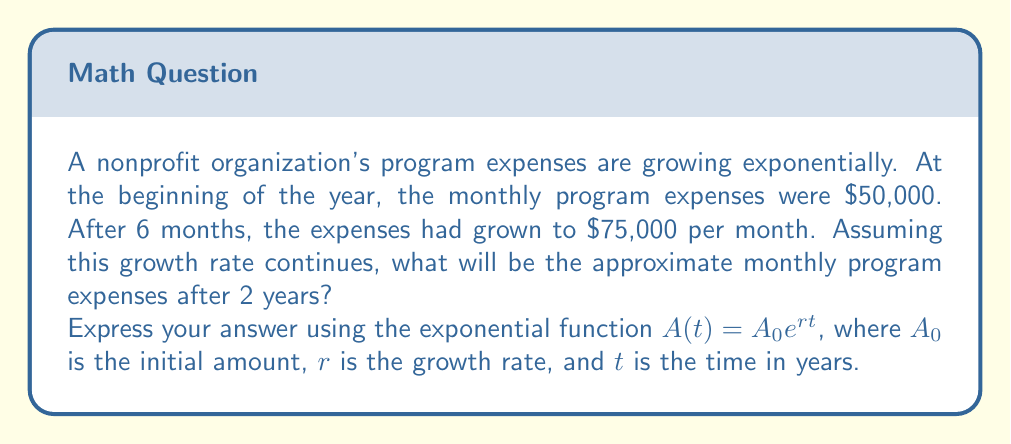Teach me how to tackle this problem. To solve this problem, we'll use the exponential growth function $A(t) = A_0e^{rt}$, where:
$A_0 = 50,000$ (initial monthly expenses)
$t = 2$ (we want to find the expenses after 2 years)

We need to find $r$ (the growth rate) using the given information:
After 6 months (0.5 years), the expenses were $75,000.

Let's set up the equation:
$75,000 = 50,000e^{r(0.5)}$

Dividing both sides by 50,000:
$1.5 = e^{0.5r}$

Taking the natural log of both sides:
$\ln(1.5) = 0.5r$

Solving for $r$:
$r = \frac{\ln(1.5)}{0.5} = 2\ln(1.5) \approx 0.8109$ per year

Now that we have $r$, we can use the original function to find the expenses after 2 years:

$A(2) = 50,000e^{0.8109(2)}$

$A(2) = 50,000e^{1.6218}$

$A(2) = 50,000 \cdot 5.0625$

$A(2) = 253,125$
Answer: $A(2) = 50,000e^{1.6218} \approx 253,125$

The approximate monthly program expenses after 2 years will be $253,125. 